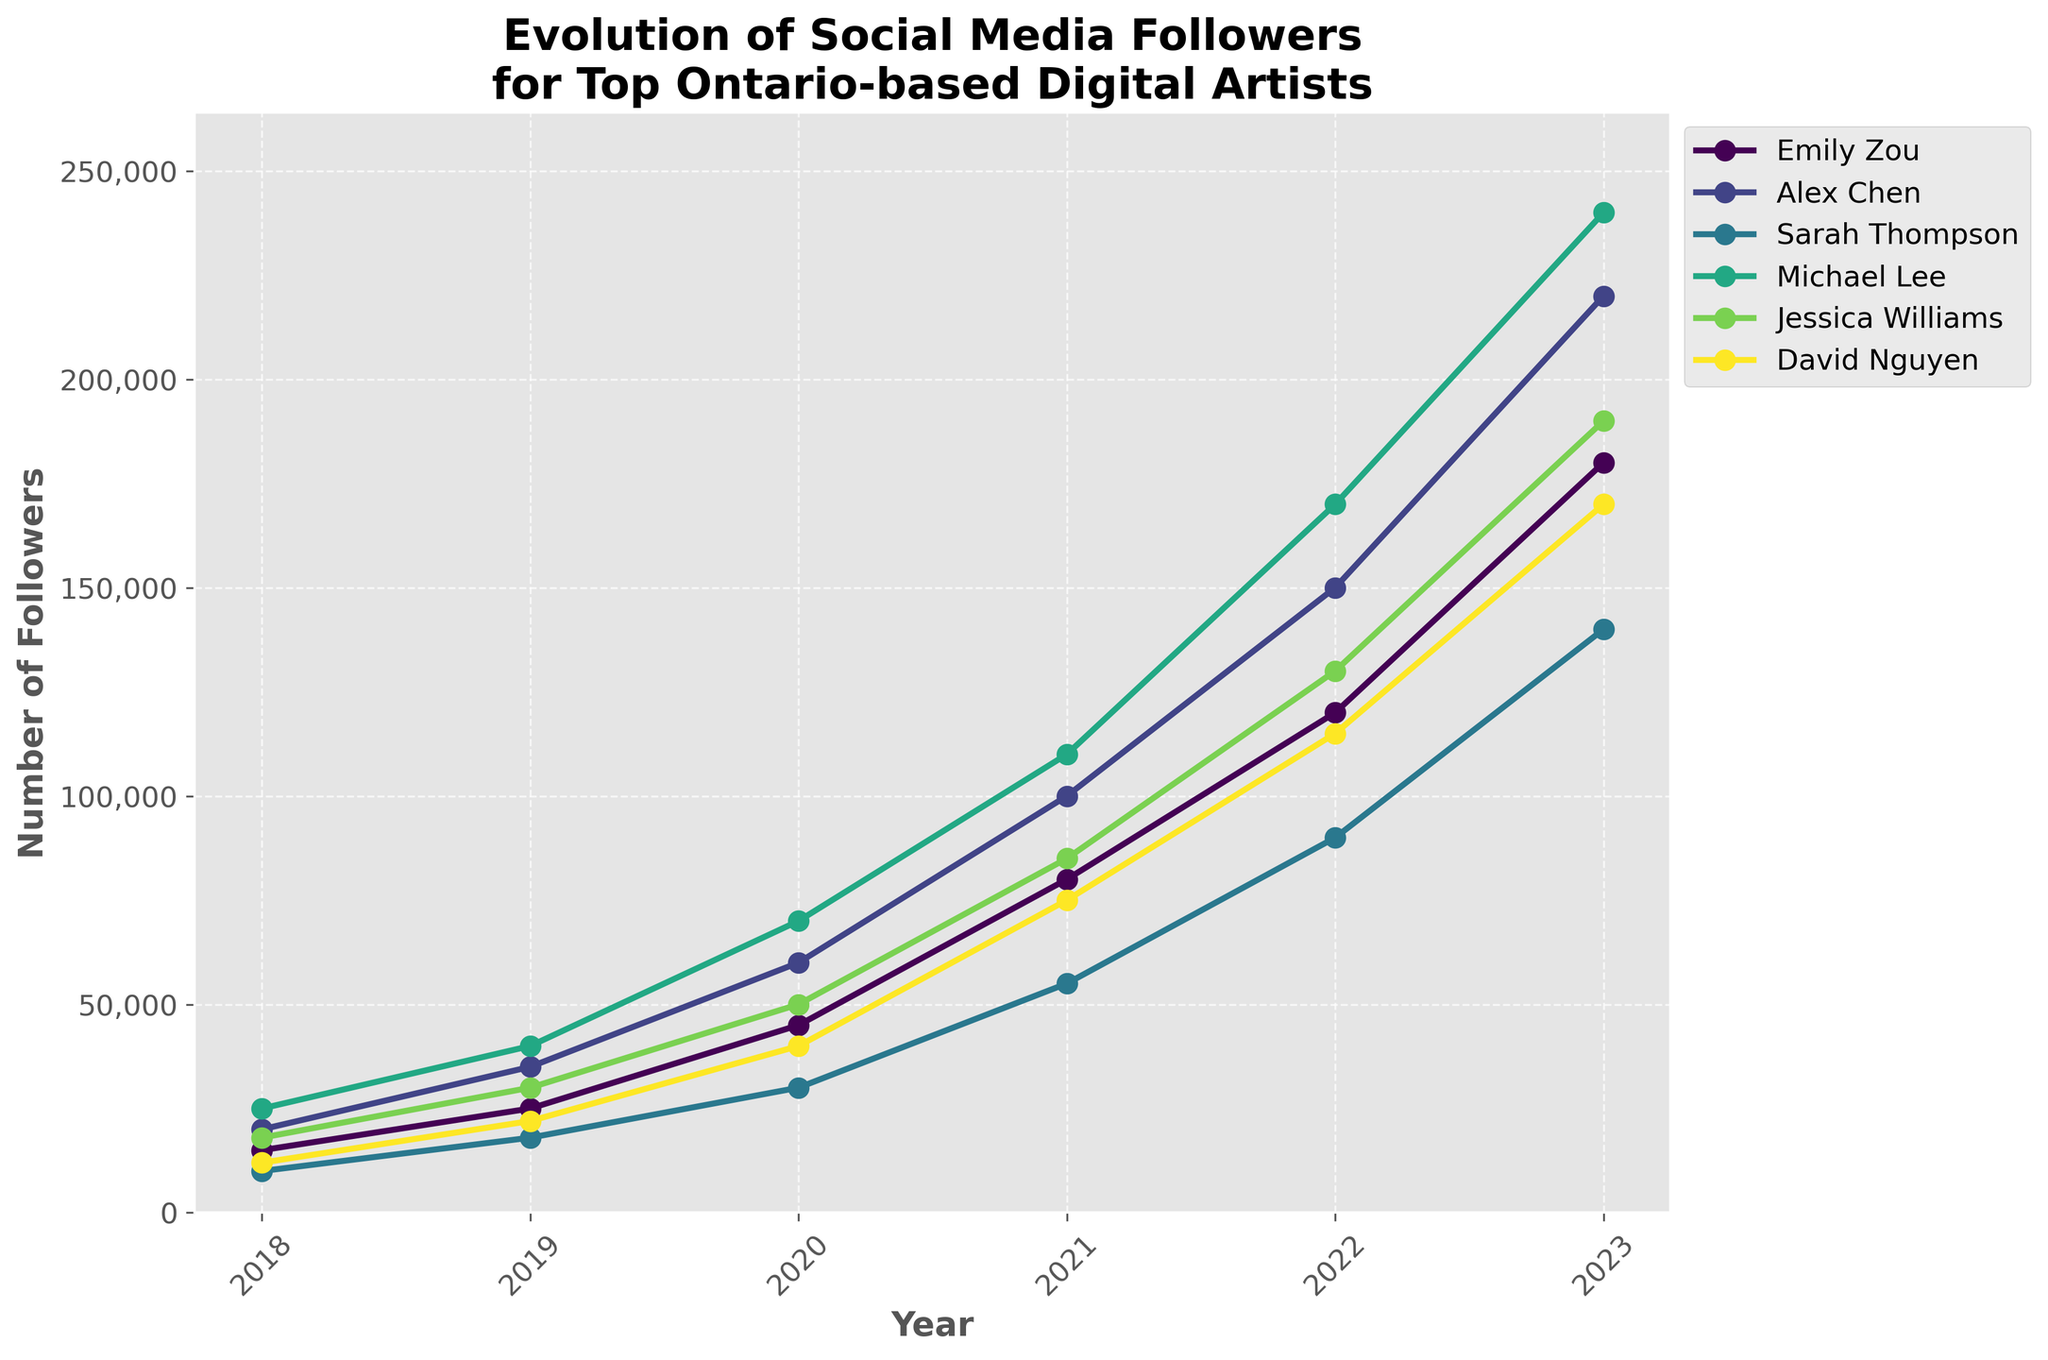Which artist had the most followers in 2023? Check the end point of each artist's line on the plot for the year 2023. The artist with the highest numerical value will be the one with the most followers.
Answer: Alex Chen Which artist saw the largest increase in followers between 2018 and 2023? For each artist, subtract their follower count in 2018 from their follower count in 2023. The artist with the highest difference had the largest increase.
Answer: Alex Chen Between 2020 and 2021, which artist experienced the least growth in their followers? Compare the differences in follower counts between 2020 and 2021 for each artist by looking directly at the plot. The smallest increase will reveal the artist with the least growth.
Answer: Sarah Thompson Do any artists have less than 20,000 followers in any given year shown on the plot? Check the starting points of all lines in 2018. If any artist's starting point is below the value of 20,000 on the y-axis, then those artists had less than 20,000 followers that year.
Answer: Yes Which artist had a steadier increase in followers over the entire period from 2018 to 2023? Look at the slopes of each line. The artist with the smoothest, least steep increase across all years indicates a steadier rise in the number of followers.
Answer: Jessica Williams Who had more followers in 2019: Emily Zou or David Nguyen? Check the points on each artist's line corresponding to the year 2019 and compare their heights on the y-axis.
Answer: Emily Zou In 2022, did Alex Chen have more followers than Michael Lee? Check the endpoints of their respective lines for the year 2022 and compare the values.
Answer: No What is the approximate average number of followers for Jessica Williams over the 6-year period? Add up the follower counts for Jessica Williams from 2018 to 2023 and then divide by 6 (the number of years).
Answer: (18000 + 30000 + 50000 + 85000 + 130000 + 190000) / 6 ≈ 83750 Which artist showed a significant jump in followers between 2018 and 2019, and what might explain this? Identify the artist with the steepest upward slope between 2018 and 2019. An explanation might be a major event or a viral post during that period.
Answer: Michael Lee, likely due to a viral event or significant project Who had the highest cumulative follower count from 2018 to 2023? Sum the follower counts for each year and compare the totals for each artist. The highest total reveals the artist with the highest cumulative followers.
Answer: Alex Chen 